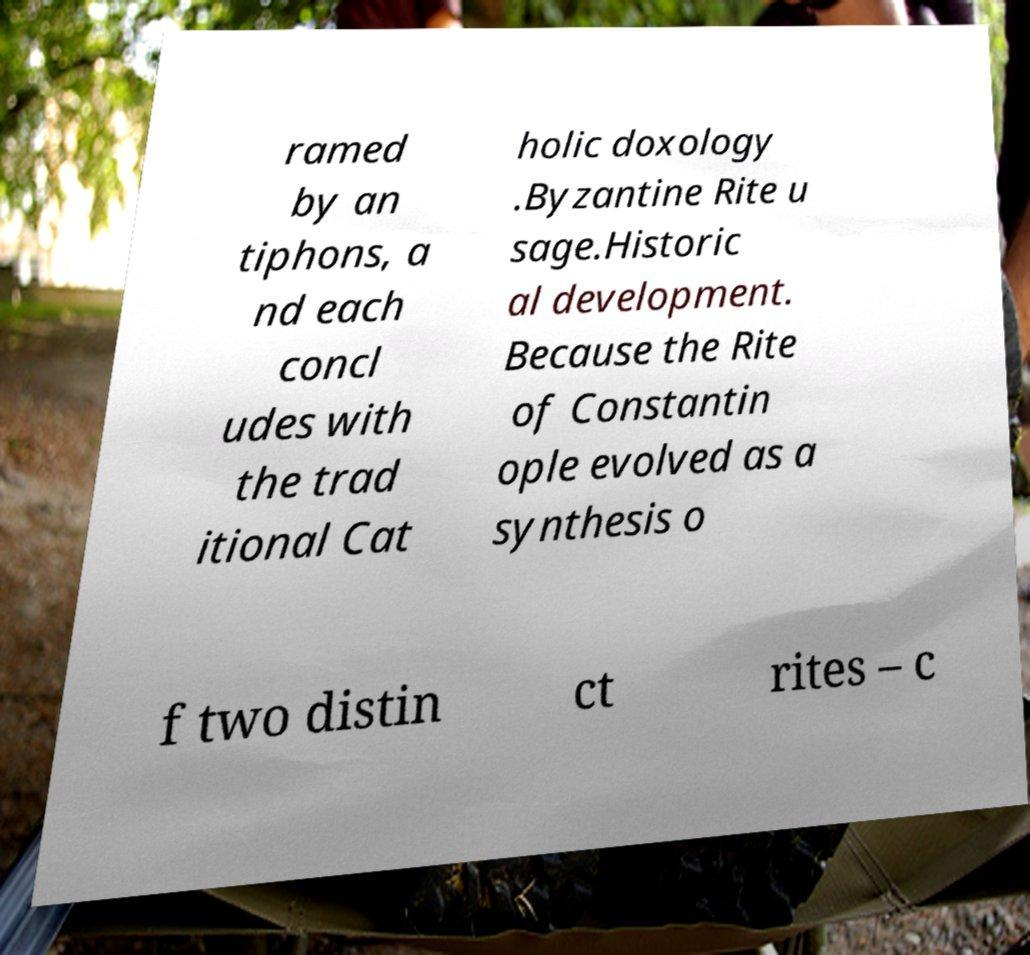There's text embedded in this image that I need extracted. Can you transcribe it verbatim? ramed by an tiphons, a nd each concl udes with the trad itional Cat holic doxology .Byzantine Rite u sage.Historic al development. Because the Rite of Constantin ople evolved as a synthesis o f two distin ct rites – c 